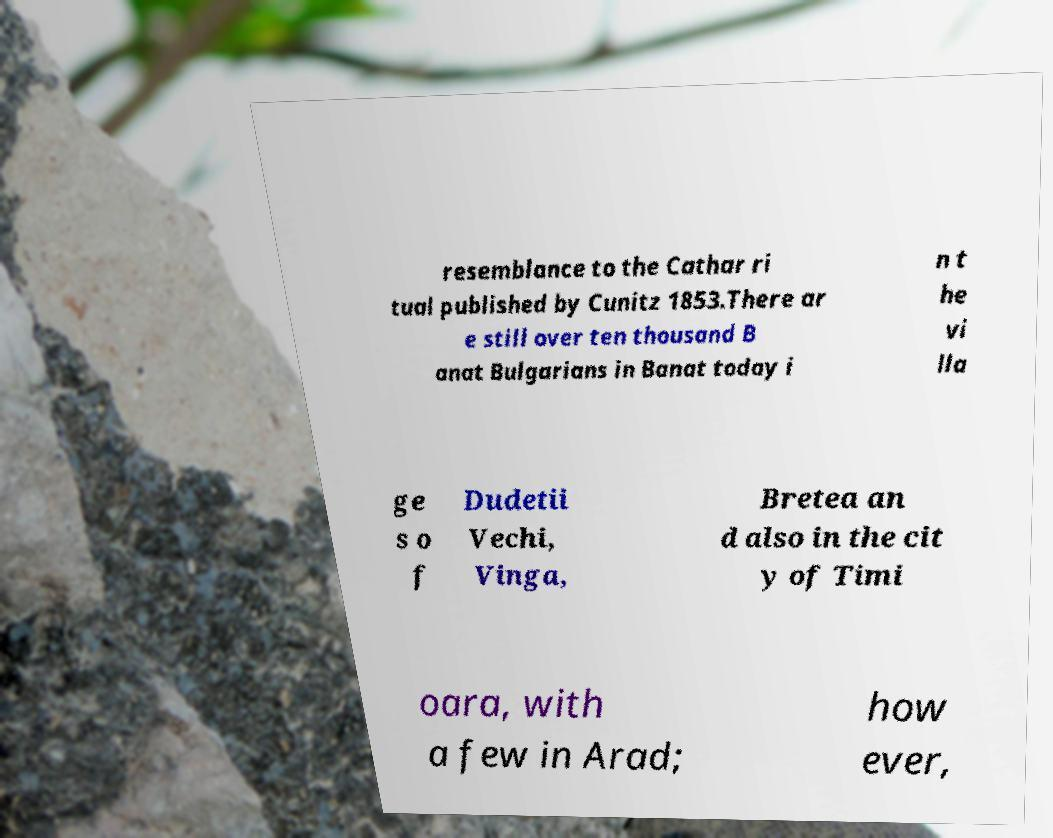Could you assist in decoding the text presented in this image and type it out clearly? resemblance to the Cathar ri tual published by Cunitz 1853.There ar e still over ten thousand B anat Bulgarians in Banat today i n t he vi lla ge s o f Dudetii Vechi, Vinga, Bretea an d also in the cit y of Timi oara, with a few in Arad; how ever, 